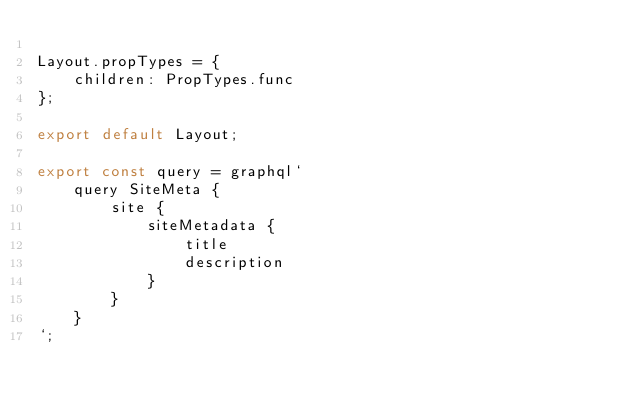<code> <loc_0><loc_0><loc_500><loc_500><_JavaScript_>
Layout.propTypes = {
	children: PropTypes.func
};

export default Layout;

export const query = graphql`
	query SiteMeta {
		site {
			siteMetadata {
				title
				description
			}
		}
	}
`;
</code> 